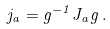Convert formula to latex. <formula><loc_0><loc_0><loc_500><loc_500>j _ { a } = g ^ { - 1 } J _ { a } g \, .</formula> 